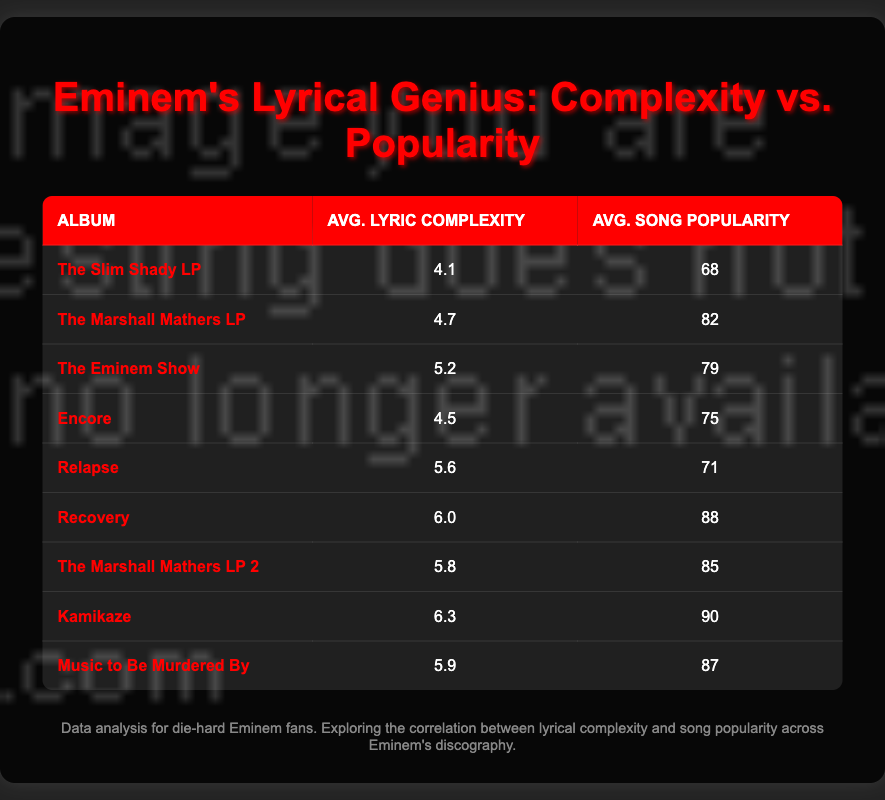What is the average lyric complexity of "Kamikaze"? The lyric complexity for "Kamikaze" is listed as 6.3 in the table.
Answer: 6.3 Which album has the highest average song popularity? "Kamikaze" has the highest average song popularity at 90, according to the table.
Answer: Kamikaze Is the average lyric complexity of "Recovery" greater than that of "Encore"? "Recovery" has an average lyric complexity of 6.0, while "Encore" has 4.5. Since 6.0 is greater than 4.5, the statement is true.
Answer: Yes What is the difference in average song popularity between "The Marshall Mathers LP" and "The Eminem Show"? "The Marshall Mathers LP" has an average song popularity of 82 and "The Eminem Show" has 79. The difference is 82 - 79 = 3.
Answer: 3 What is the average lyric complexity across all albums listed? To find the average, we sum the average lyric complexities (4.1 + 4.7 + 5.2 + 4.5 + 5.6 + 6.0 + 5.8 + 6.3 + 5.9 = 54.1) and divide by the number of albums (9). The average is 54.1 / 9 = 6.01.
Answer: 6.01 How many albums have an average lyric complexity above 5? The albums exceeding a complexity of 5 are "Relapse" (5.6), "Recovery" (6.0), "The Marshall Mathers LP 2" (5.8), "Kamikaze" (6.3), and "Music to Be Murdered By" (5.9), totaling 5 albums.
Answer: 5 Did "The Slim Shady LP" have a higher average lyric complexity than "Encore"? "The Slim Shady LP" has an average lyric complexity of 4.1, while "Encore" has 4.5. Since 4.1 is less than 4.5, the statement is false.
Answer: No What is the total average song popularity of albums with an average lyric complexity under 5? The albums are "The Slim Shady LP" (68), "The Marshall Mathers LP" (82), and "Encore" (75). Their total popularity is 68 + 82 + 75 = 225; there are 3 albums, so 225 / 3 = 75.
Answer: 75 